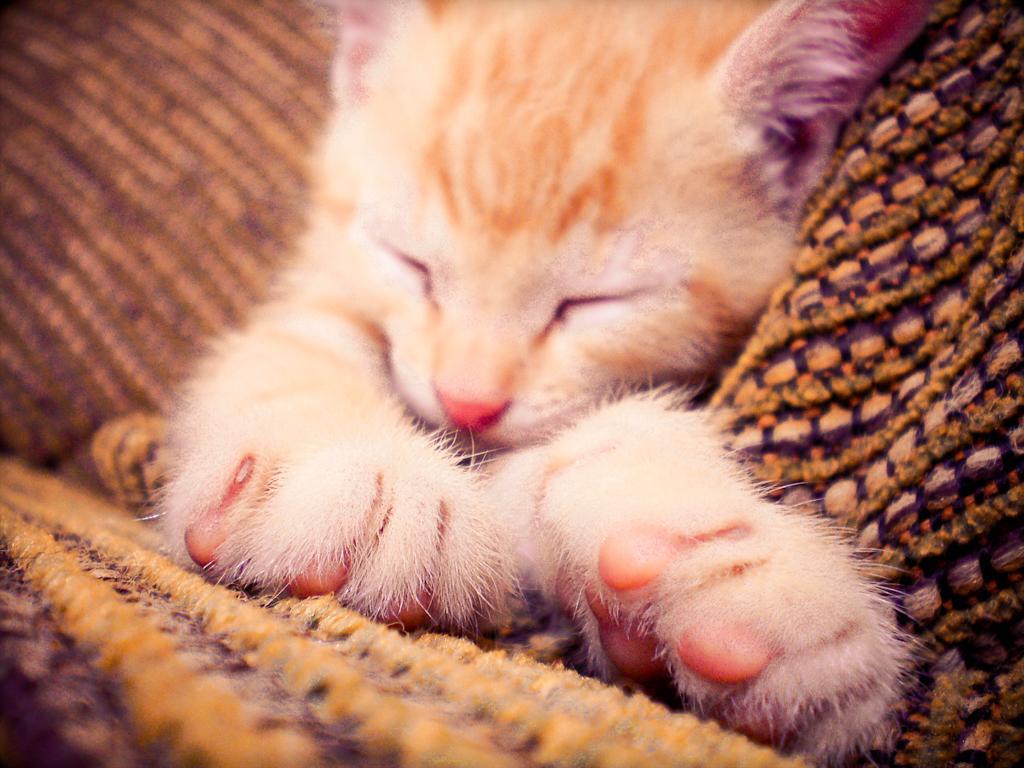Could you give a brief overview of what you see in this image? In this image we can see the sleeping cat on the mat. 